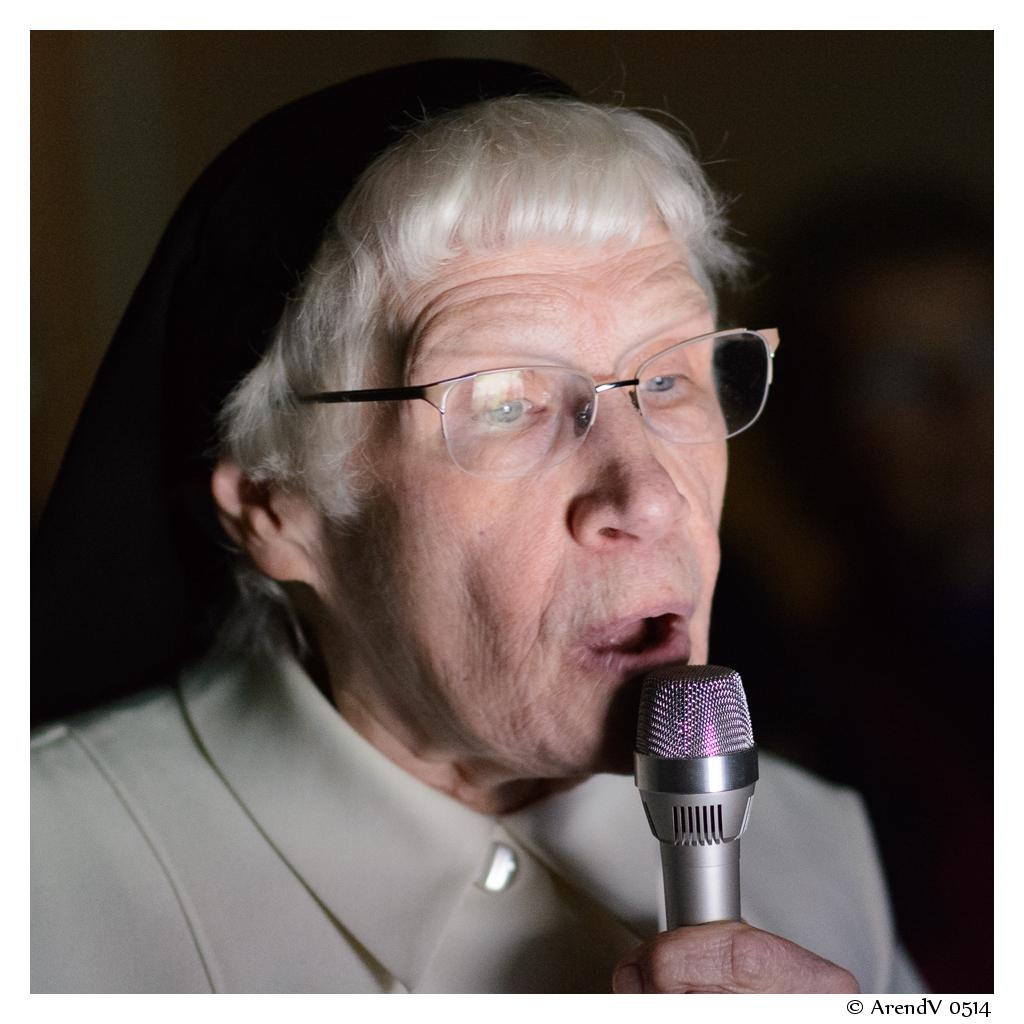What can be seen in the image? There is a person in the image. Can you describe the person's appearance? The person is wearing spectacles. What is the person holding in the image? The person is holding a microphone (mike). What type of bee can be seen buzzing around the person in the image? There is no bee present in the image. Can you describe the bird that is perched on the person's shoulder in the image? There is no bird present in the image. 